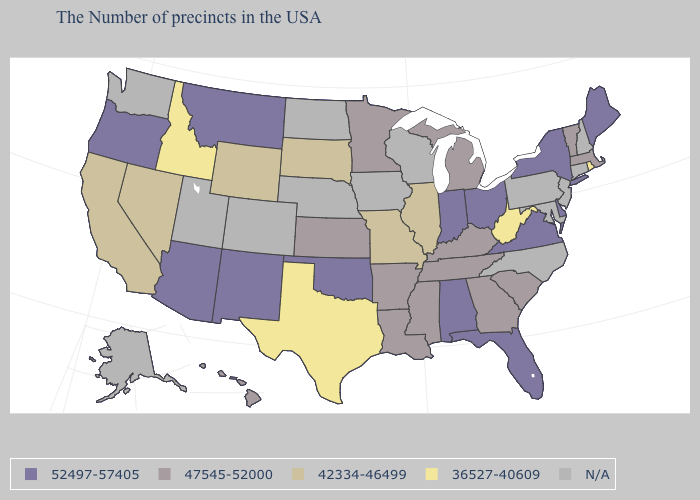What is the lowest value in the MidWest?
Short answer required. 42334-46499. Is the legend a continuous bar?
Keep it brief. No. How many symbols are there in the legend?
Write a very short answer. 5. Name the states that have a value in the range 47545-52000?
Concise answer only. Massachusetts, Vermont, South Carolina, Georgia, Michigan, Kentucky, Tennessee, Mississippi, Louisiana, Arkansas, Minnesota, Kansas, Hawaii. Does the map have missing data?
Answer briefly. Yes. What is the value of Minnesota?
Short answer required. 47545-52000. What is the lowest value in the USA?
Give a very brief answer. 36527-40609. Does the map have missing data?
Quick response, please. Yes. What is the value of North Carolina?
Short answer required. N/A. Name the states that have a value in the range 52497-57405?
Quick response, please. Maine, New York, Delaware, Virginia, Ohio, Florida, Indiana, Alabama, Oklahoma, New Mexico, Montana, Arizona, Oregon. Does the first symbol in the legend represent the smallest category?
Keep it brief. No. Which states hav the highest value in the West?
Concise answer only. New Mexico, Montana, Arizona, Oregon. Does the map have missing data?
Answer briefly. Yes. What is the highest value in states that border Vermont?
Quick response, please. 52497-57405. 